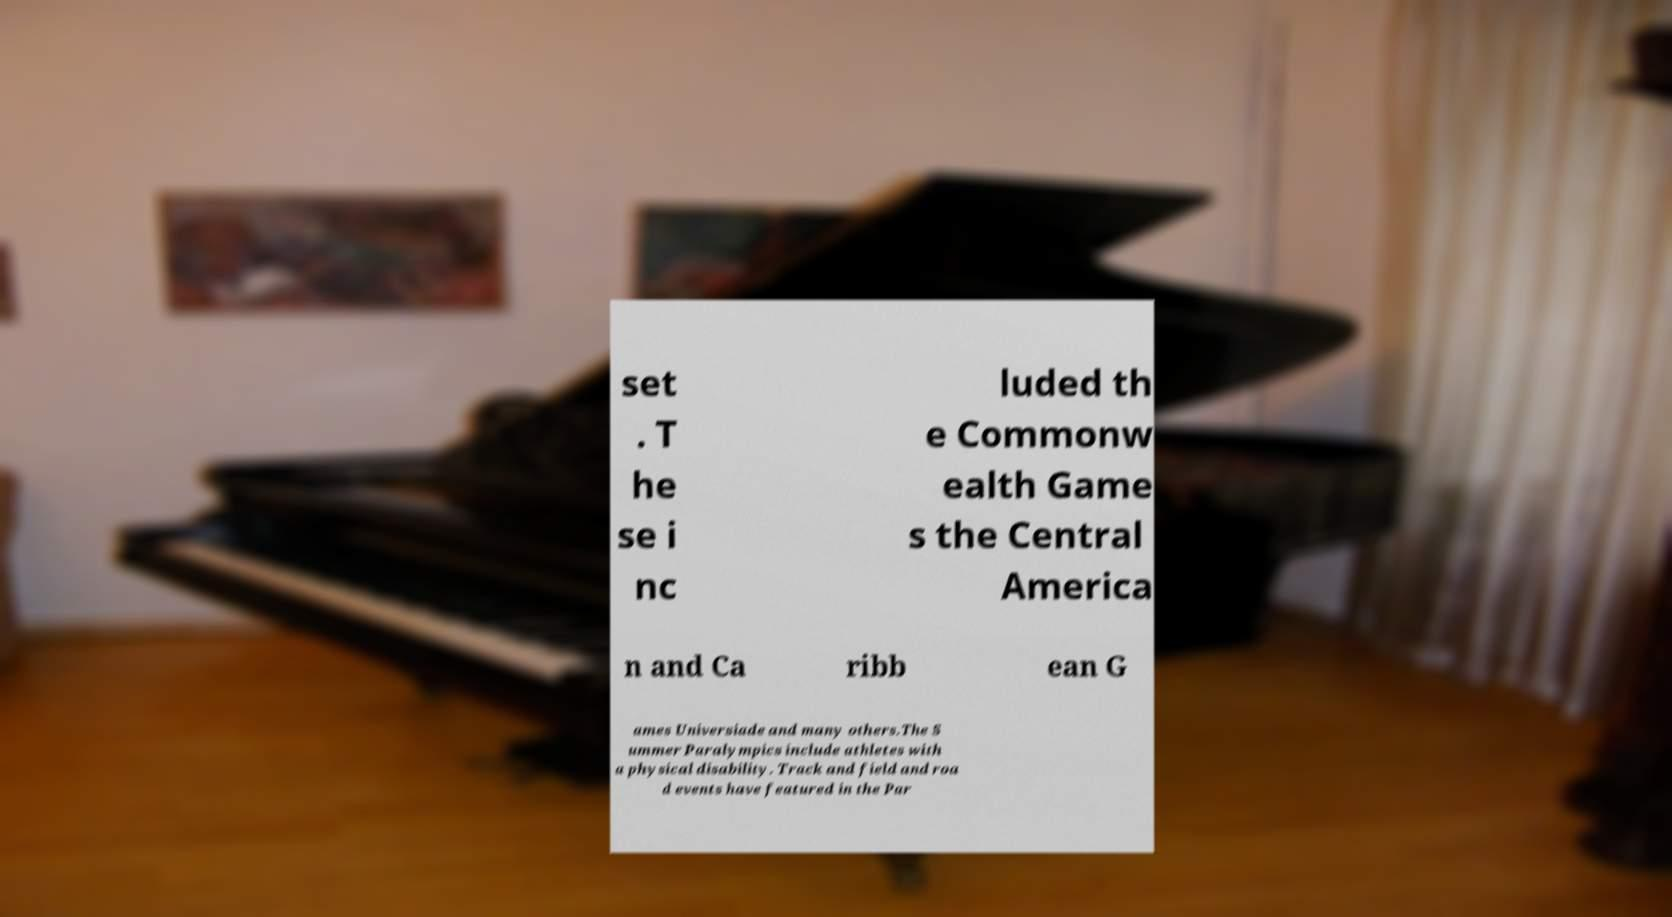Could you extract and type out the text from this image? set . T he se i nc luded th e Commonw ealth Game s the Central America n and Ca ribb ean G ames Universiade and many others.The S ummer Paralympics include athletes with a physical disability. Track and field and roa d events have featured in the Par 